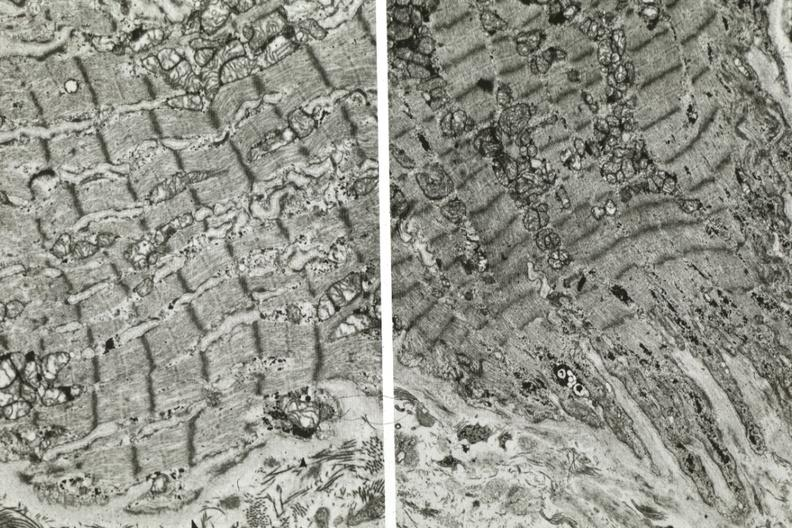where is this area in the body?
Answer the question using a single word or phrase. Heart 